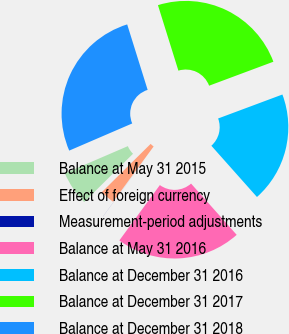Convert chart to OTSL. <chart><loc_0><loc_0><loc_500><loc_500><pie_chart><fcel>Balance at May 31 2015<fcel>Effect of foreign currency<fcel>Measurement-period adjustments<fcel>Balance at May 31 2016<fcel>Balance at December 31 2016<fcel>Balance at December 31 2017<fcel>Balance at December 31 2018<nl><fcel>5.93%<fcel>2.53%<fcel>0.01%<fcel>21.63%<fcel>19.11%<fcel>24.14%<fcel>26.66%<nl></chart> 